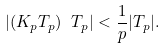<formula> <loc_0><loc_0><loc_500><loc_500>| ( K _ { p } T _ { p } ) \ T _ { p } | < \frac { 1 } { p } | T _ { p } | .</formula> 